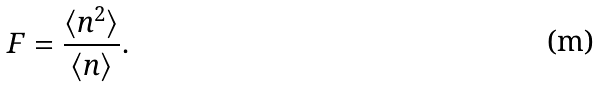<formula> <loc_0><loc_0><loc_500><loc_500>F = \frac { \langle n ^ { 2 } \rangle } { \langle n \rangle } .</formula> 